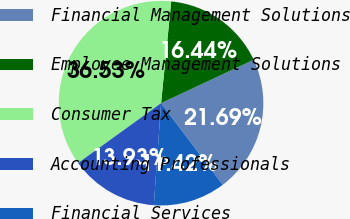Convert chart to OTSL. <chart><loc_0><loc_0><loc_500><loc_500><pie_chart><fcel>Financial Management Solutions<fcel>Employee Management Solutions<fcel>Consumer Tax<fcel>Accounting Professionals<fcel>Financial Services<nl><fcel>21.69%<fcel>16.44%<fcel>36.53%<fcel>13.93%<fcel>11.42%<nl></chart> 